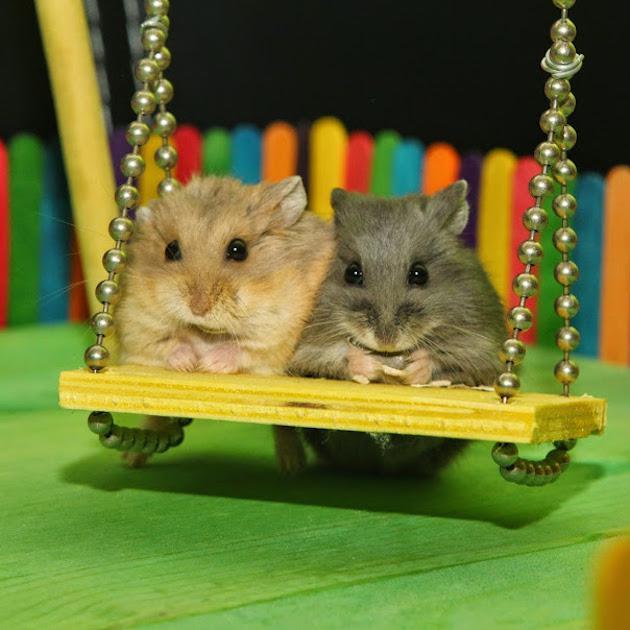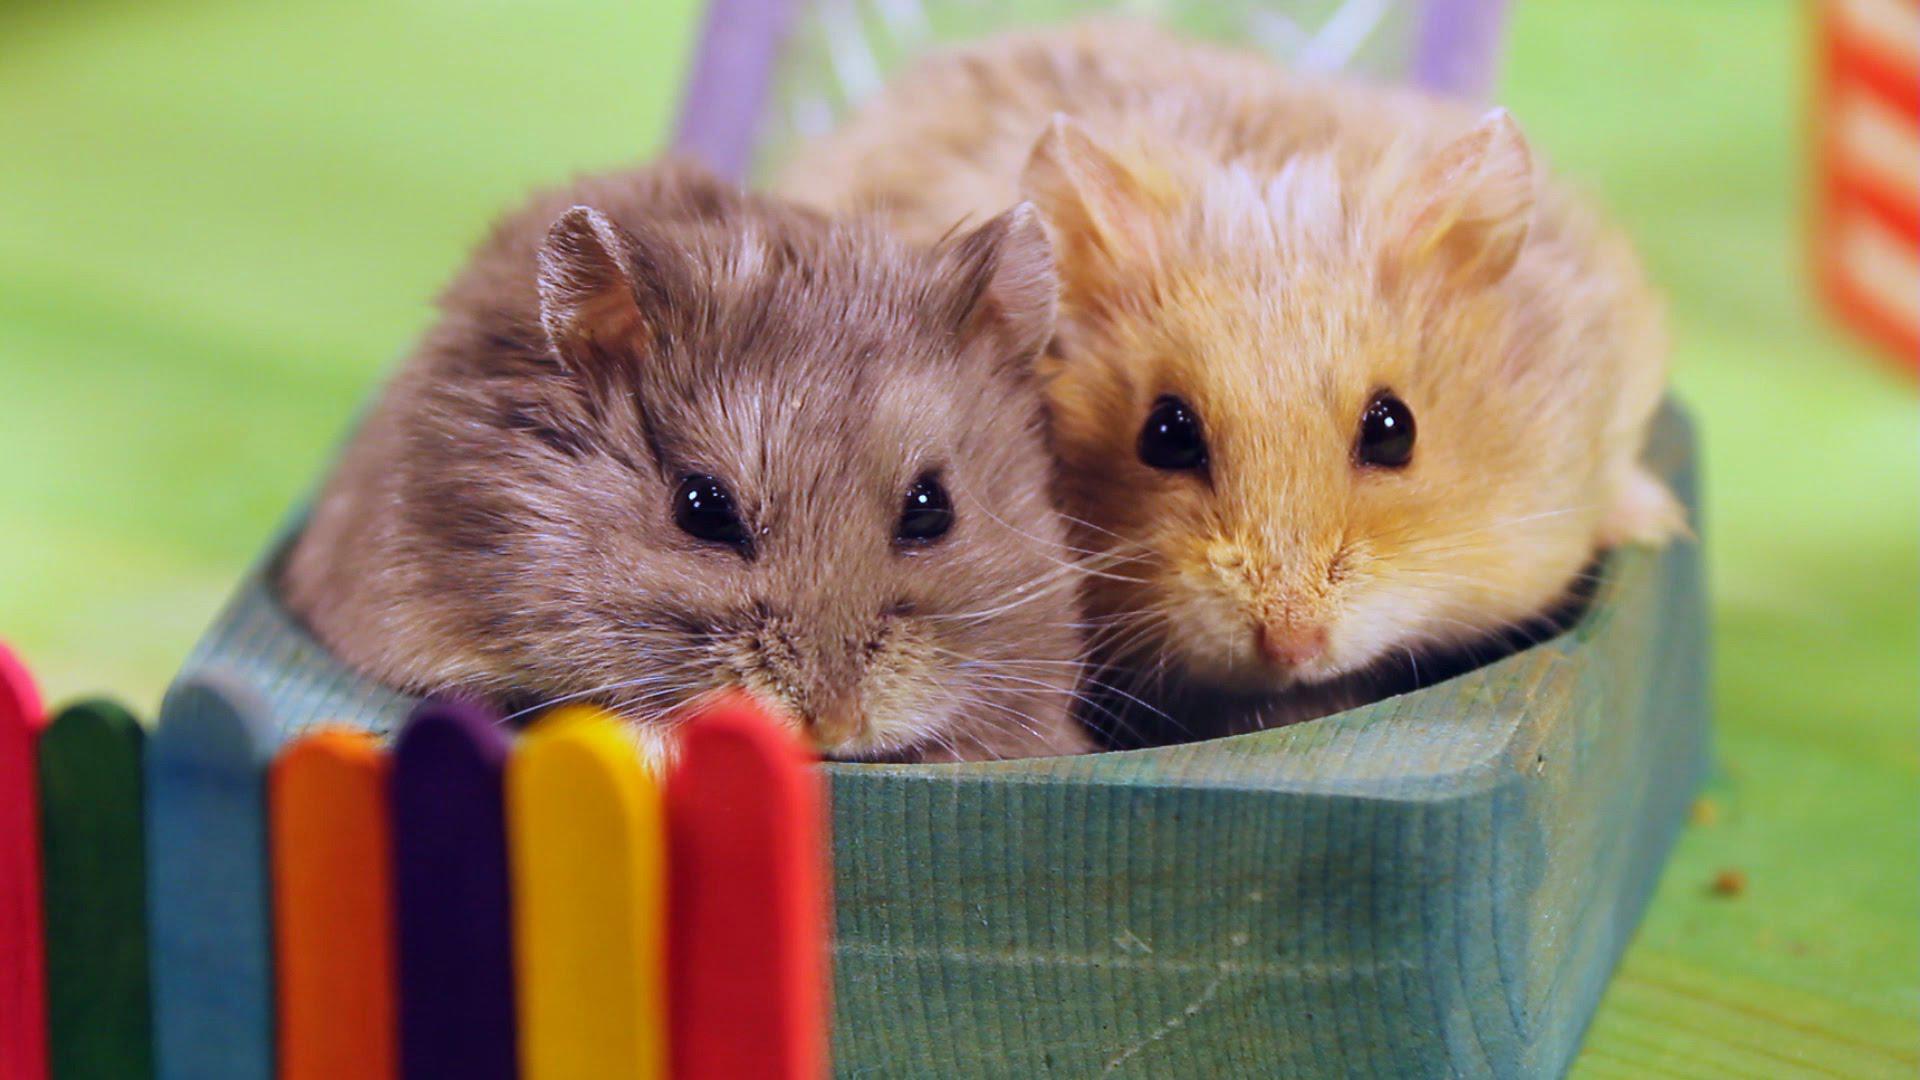The first image is the image on the left, the second image is the image on the right. For the images displayed, is the sentence "Th e image on the left contains two hamsters." factually correct? Answer yes or no. Yes. The first image is the image on the left, the second image is the image on the right. Examine the images to the left and right. Is the description "Two hamsters are on swings." accurate? Answer yes or no. Yes. 